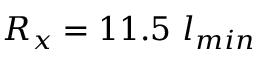<formula> <loc_0><loc_0><loc_500><loc_500>R _ { x } = 1 1 . 5 l _ { \min }</formula> 